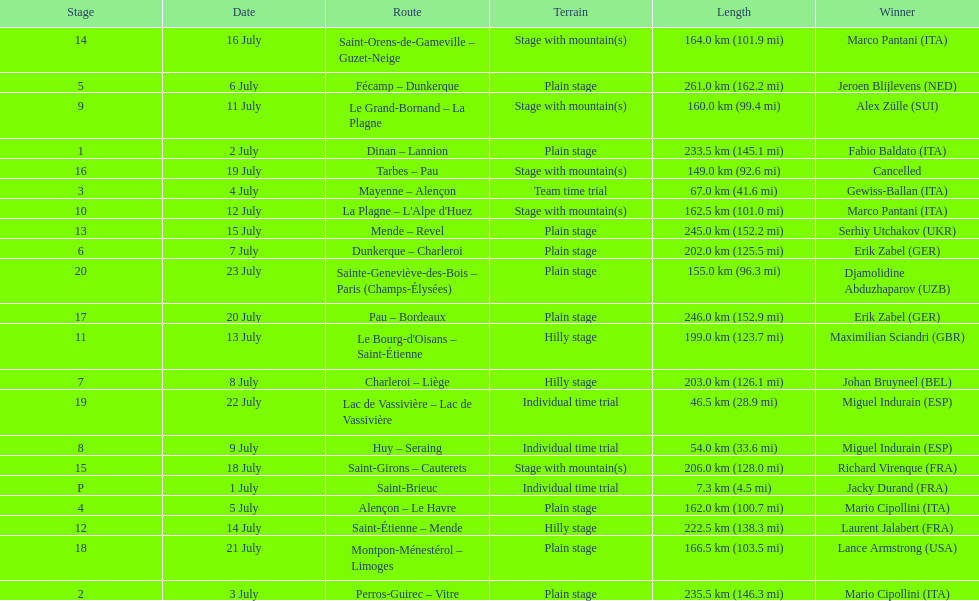Which routes were at least 100 km? Dinan - Lannion, Perros-Guirec - Vitre, Alençon - Le Havre, Fécamp - Dunkerque, Dunkerque - Charleroi, Charleroi - Liège, Le Grand-Bornand - La Plagne, La Plagne - L'Alpe d'Huez, Le Bourg-d'Oisans - Saint-Étienne, Saint-Étienne - Mende, Mende - Revel, Saint-Orens-de-Gameville - Guzet-Neige, Saint-Girons - Cauterets, Tarbes - Pau, Pau - Bordeaux, Montpon-Ménestérol - Limoges, Sainte-Geneviève-des-Bois - Paris (Champs-Élysées). 